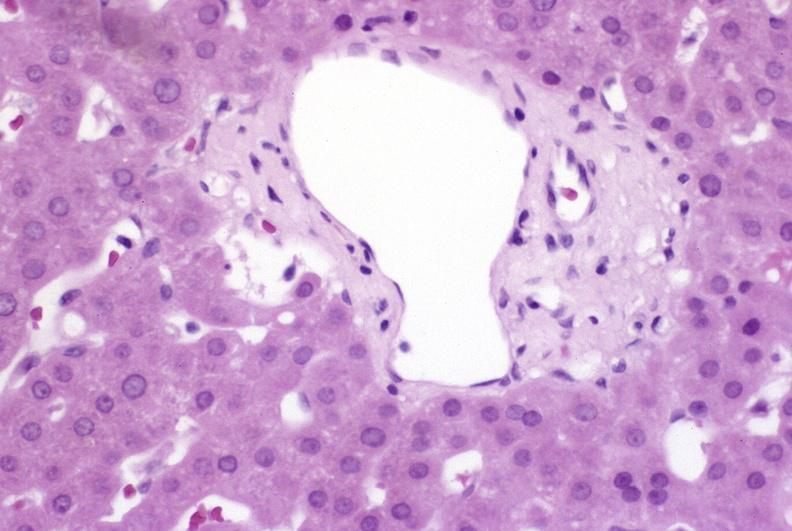what does this image show?
Answer the question using a single word or phrase. Ductopenia 